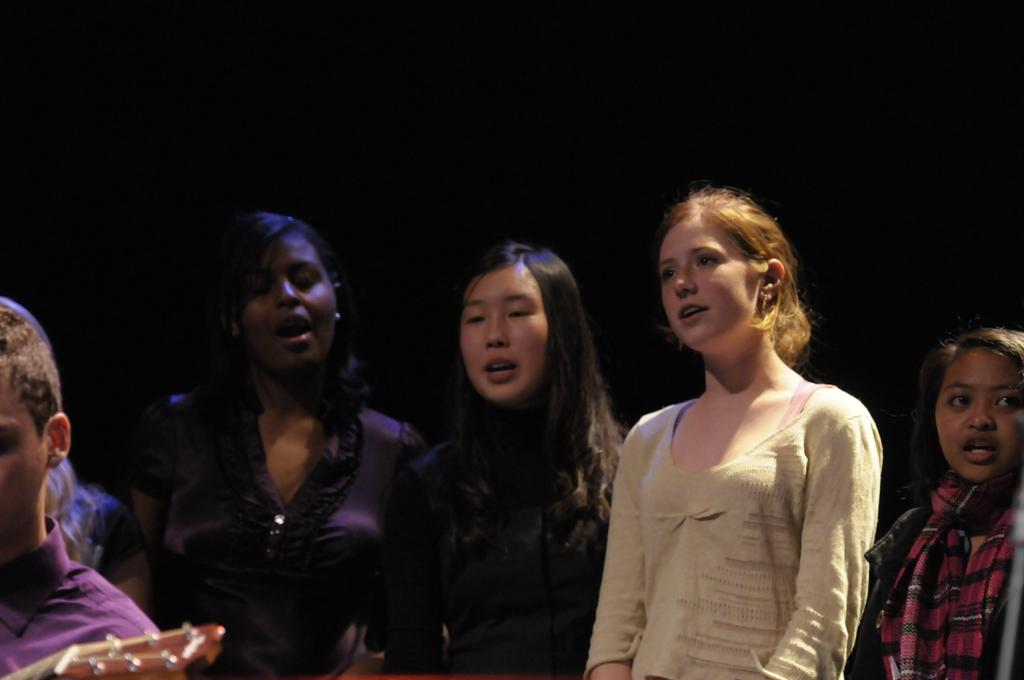What is happening in the image involving a group of people? There is a group of people in the image, and some of them are singing. Can you describe the person on the left side of the image? The person on the left side of the image is holding a guitar. What type of hammer is being used by the person in the image? There is no hammer present in the image; the person on the left side is holding a guitar. What kind of apparel is the person wearing in the image? The provided facts do not mention any specific apparel worn by the people in the image. 